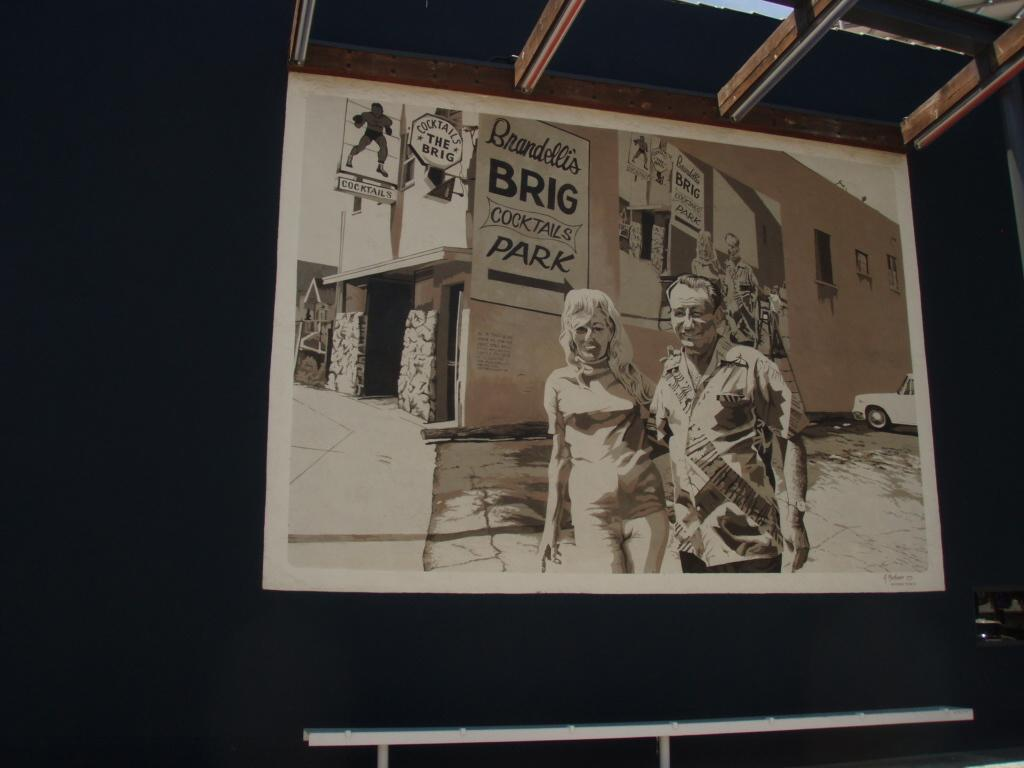<image>
Render a clear and concise summary of the photo. a poster that says brandellis brig cocktails park' on it 